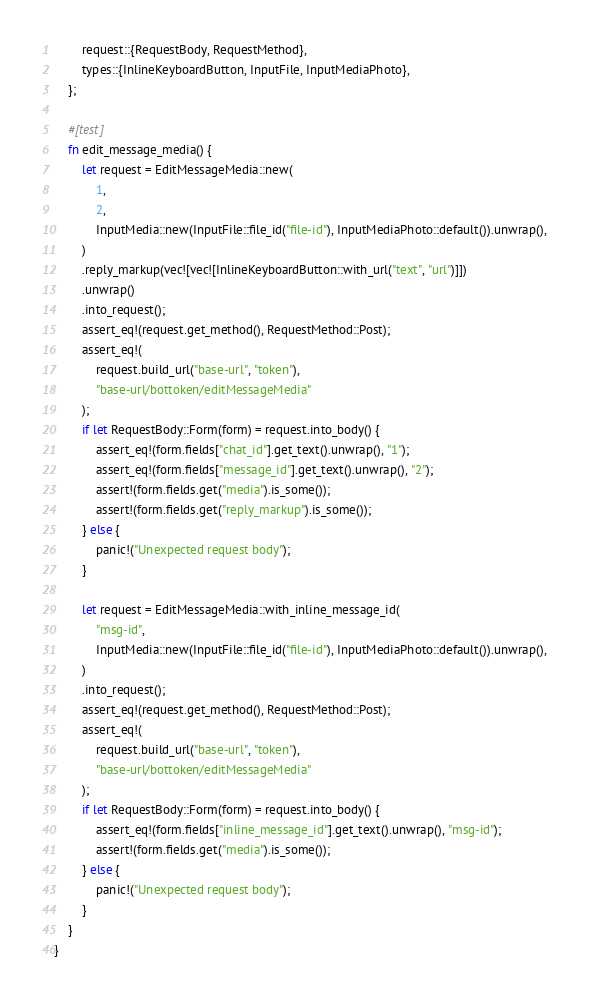Convert code to text. <code><loc_0><loc_0><loc_500><loc_500><_Rust_>        request::{RequestBody, RequestMethod},
        types::{InlineKeyboardButton, InputFile, InputMediaPhoto},
    };

    #[test]
    fn edit_message_media() {
        let request = EditMessageMedia::new(
            1,
            2,
            InputMedia::new(InputFile::file_id("file-id"), InputMediaPhoto::default()).unwrap(),
        )
        .reply_markup(vec![vec![InlineKeyboardButton::with_url("text", "url")]])
        .unwrap()
        .into_request();
        assert_eq!(request.get_method(), RequestMethod::Post);
        assert_eq!(
            request.build_url("base-url", "token"),
            "base-url/bottoken/editMessageMedia"
        );
        if let RequestBody::Form(form) = request.into_body() {
            assert_eq!(form.fields["chat_id"].get_text().unwrap(), "1");
            assert_eq!(form.fields["message_id"].get_text().unwrap(), "2");
            assert!(form.fields.get("media").is_some());
            assert!(form.fields.get("reply_markup").is_some());
        } else {
            panic!("Unexpected request body");
        }

        let request = EditMessageMedia::with_inline_message_id(
            "msg-id",
            InputMedia::new(InputFile::file_id("file-id"), InputMediaPhoto::default()).unwrap(),
        )
        .into_request();
        assert_eq!(request.get_method(), RequestMethod::Post);
        assert_eq!(
            request.build_url("base-url", "token"),
            "base-url/bottoken/editMessageMedia"
        );
        if let RequestBody::Form(form) = request.into_body() {
            assert_eq!(form.fields["inline_message_id"].get_text().unwrap(), "msg-id");
            assert!(form.fields.get("media").is_some());
        } else {
            panic!("Unexpected request body");
        }
    }
}
</code> 